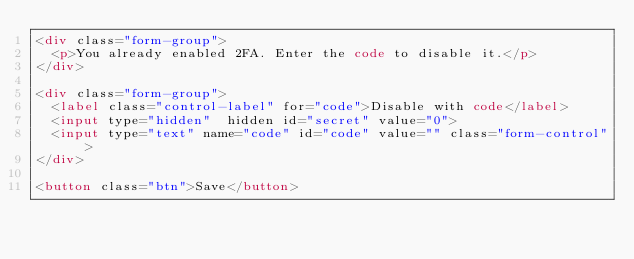<code> <loc_0><loc_0><loc_500><loc_500><_HTML_><div class="form-group">
  <p>You already enabled 2FA. Enter the code to disable it.</p>
</div>

<div class="form-group">
  <label class="control-label" for="code">Disable with code</label>
  <input type="hidden"  hidden id="secret" value="0">
  <input type="text" name="code" id="code" value="" class="form-control">
</div>

<button class="btn">Save</button>
</code> 